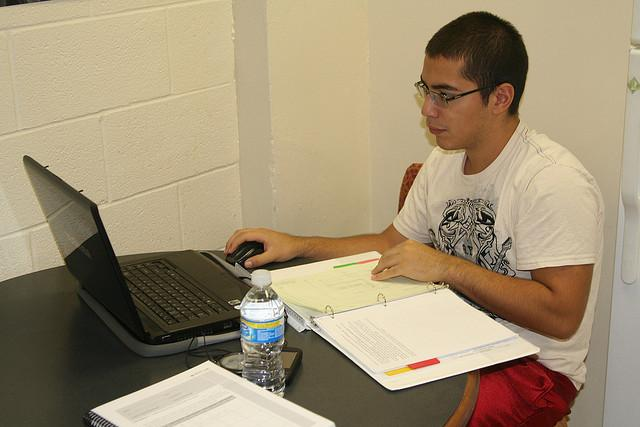Where is this student studying? Please explain your reasoning. dormitory. A man is sitting at a table as he studies on the laptop. 